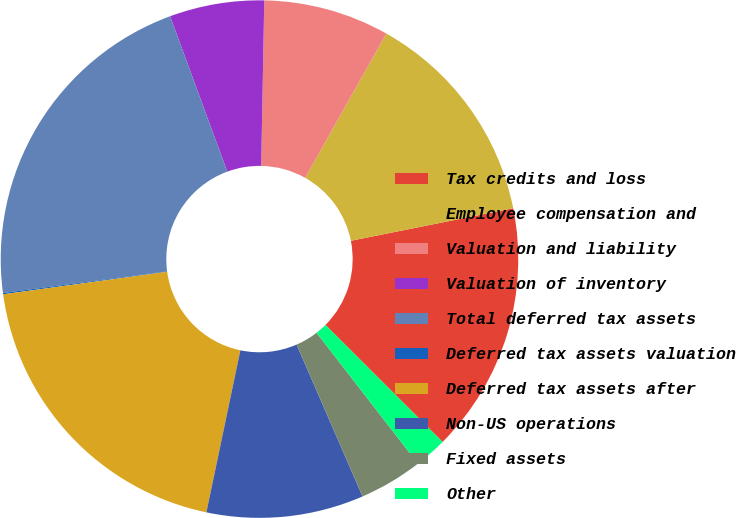Convert chart to OTSL. <chart><loc_0><loc_0><loc_500><loc_500><pie_chart><fcel>Tax credits and loss<fcel>Employee compensation and<fcel>Valuation and liability<fcel>Valuation of inventory<fcel>Total deferred tax assets<fcel>Deferred tax assets valuation<fcel>Deferred tax assets after<fcel>Non-US operations<fcel>Fixed assets<fcel>Other<nl><fcel>15.64%<fcel>13.7%<fcel>7.86%<fcel>5.91%<fcel>21.48%<fcel>0.08%<fcel>19.54%<fcel>9.81%<fcel>3.97%<fcel>2.02%<nl></chart> 